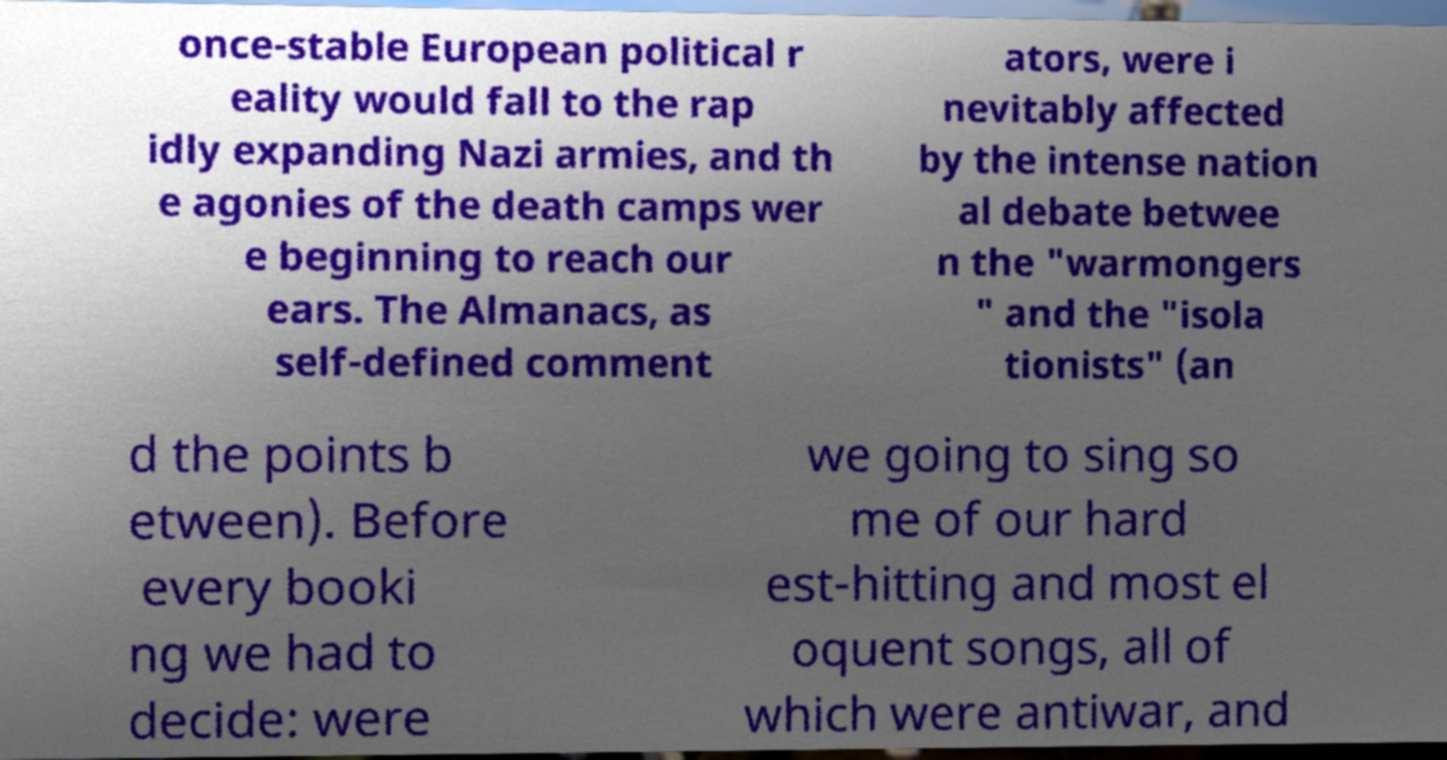Please read and relay the text visible in this image. What does it say? once-stable European political r eality would fall to the rap idly expanding Nazi armies, and th e agonies of the death camps wer e beginning to reach our ears. The Almanacs, as self-defined comment ators, were i nevitably affected by the intense nation al debate betwee n the "warmongers " and the "isola tionists" (an d the points b etween). Before every booki ng we had to decide: were we going to sing so me of our hard est-hitting and most el oquent songs, all of which were antiwar, and 